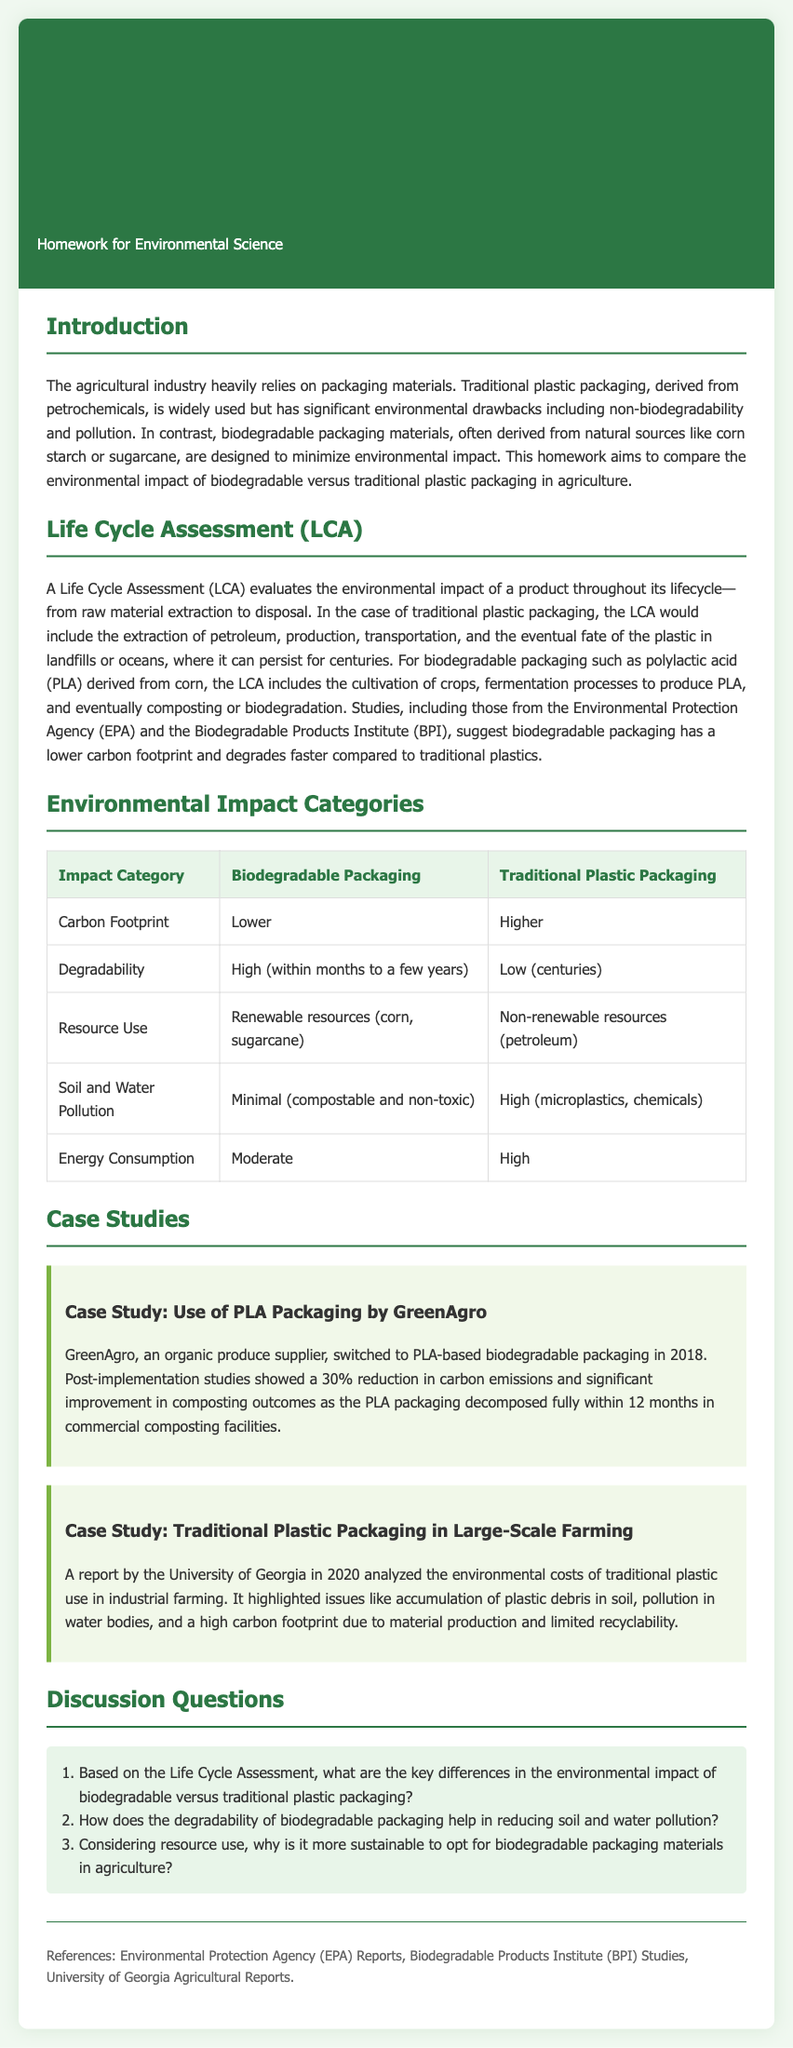What is the main focus of the homework? The homework aims to compare the environmental impact of biodegradable versus traditional plastic packaging in agriculture.
Answer: Compare environmental impact What packaging material did GreenAgro switch to in 2018? GreenAgro switched to PLA-based biodegradable packaging in 2018.
Answer: PLA-based biodegradable packaging What percentage reduction in carbon emissions did GreenAgro achieve? Post-implementation studies showed a 30% reduction in carbon emissions.
Answer: 30% What resources are used for biodegradable packaging? Biodegradable packaging uses renewable resources such as corn and sugarcane.
Answer: Renewable resources How long does traditional plastic packaging take to degrade? Traditional plastic packaging can persist for centuries.
Answer: Centuries What is the carbon footprint comparison between biodegradable and traditional plastic packaging? Biodegradable packaging has a lower carbon footprint compared to traditional plastic.
Answer: Lower What are the two main categories of packaging discussed in the environmental impact analysis? The analysis discusses biodegradable and traditional plastic packaging categories.
Answer: Biodegradable and traditional plastic What type of analysis is used to evaluate the environmental impact? A Life Cycle Assessment (LCA) is used to evaluate the environmental impact of packaging.
Answer: Life Cycle Assessment (LCA) What is the main environmental issue raised by the University of Georgia report regarding traditional plastic? The report highlighted accumulation of plastic debris in soil and pollution in water bodies.
Answer: Accumulation of plastic debris in soil 